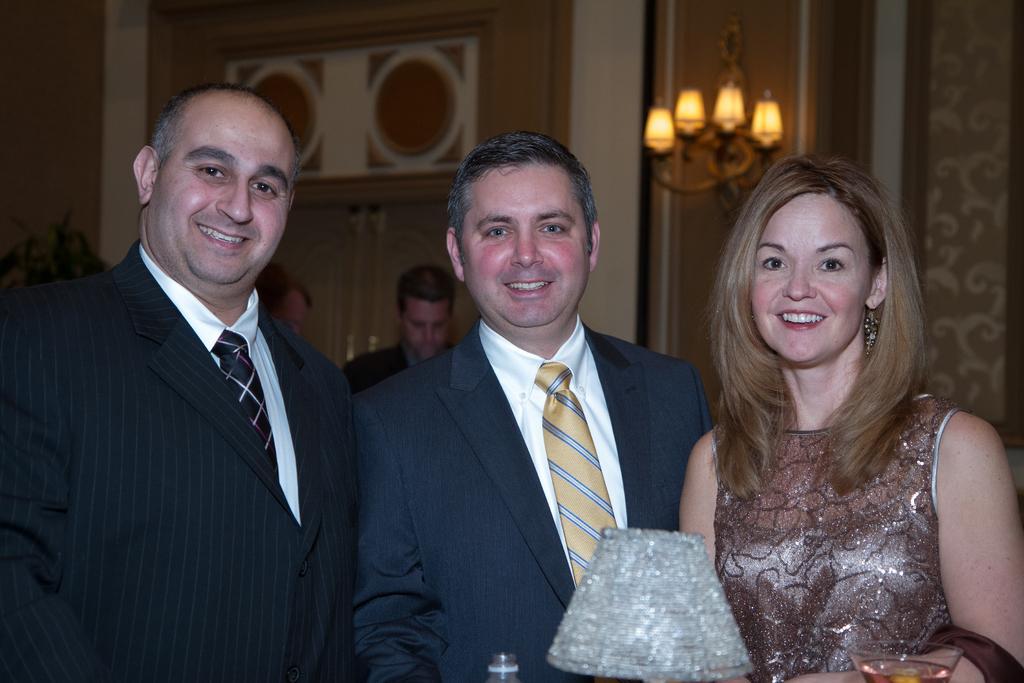In one or two sentences, can you explain what this image depicts? In this image we can see persons standing and some of them are smiling. In the background there are walls, chandelier, disposal bottle and a glass tumbler with beverage in it. 